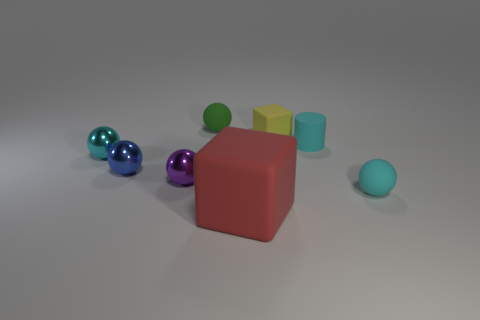What color is the tiny block?
Provide a short and direct response. Yellow. How many cylinders are on the left side of the small cyan ball that is to the left of the small cube?
Your answer should be very brief. 0. What size is the matte thing that is both on the left side of the tiny yellow rubber thing and in front of the small cyan rubber cylinder?
Provide a succinct answer. Large. There is a cyan thing behind the small cyan metal ball; what material is it?
Your answer should be very brief. Rubber. Is there a big red matte thing that has the same shape as the yellow matte thing?
Make the answer very short. Yes. How many tiny brown objects have the same shape as the tiny purple metallic thing?
Provide a short and direct response. 0. Do the cyan object in front of the purple metallic thing and the metal object that is on the left side of the blue sphere have the same size?
Provide a short and direct response. Yes. What is the shape of the cyan object behind the tiny cyan sphere that is to the left of the big matte block?
Give a very brief answer. Cylinder. Are there an equal number of small blue balls that are right of the small green sphere and tiny red cylinders?
Ensure brevity in your answer.  Yes. The cyan sphere in front of the cyan ball that is behind the cyan rubber ball that is behind the red block is made of what material?
Provide a short and direct response. Rubber. 